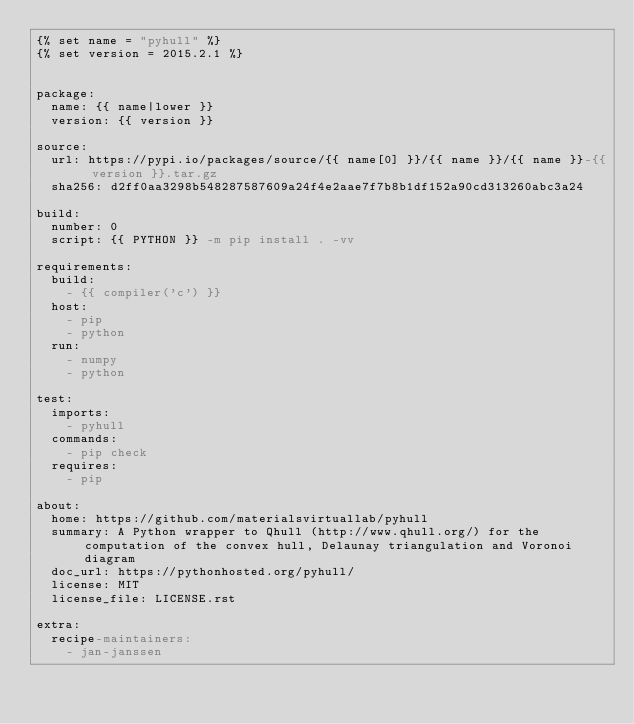<code> <loc_0><loc_0><loc_500><loc_500><_YAML_>{% set name = "pyhull" %}
{% set version = 2015.2.1 %}


package:
  name: {{ name|lower }}
  version: {{ version }}

source:
  url: https://pypi.io/packages/source/{{ name[0] }}/{{ name }}/{{ name }}-{{ version }}.tar.gz
  sha256: d2ff0aa3298b548287587609a24f4e2aae7f7b8b1df152a90cd313260abc3a24

build:
  number: 0
  script: {{ PYTHON }} -m pip install . -vv

requirements:
  build:
    - {{ compiler('c') }}
  host:
    - pip
    - python
  run:
    - numpy
    - python

test:
  imports:
    - pyhull
  commands:
    - pip check
  requires:
    - pip

about:
  home: https://github.com/materialsvirtuallab/pyhull
  summary: A Python wrapper to Qhull (http://www.qhull.org/) for the computation of the convex hull, Delaunay triangulation and Voronoi diagram
  doc_url: https://pythonhosted.org/pyhull/
  license: MIT
  license_file: LICENSE.rst

extra:
  recipe-maintainers:
    - jan-janssen
</code> 